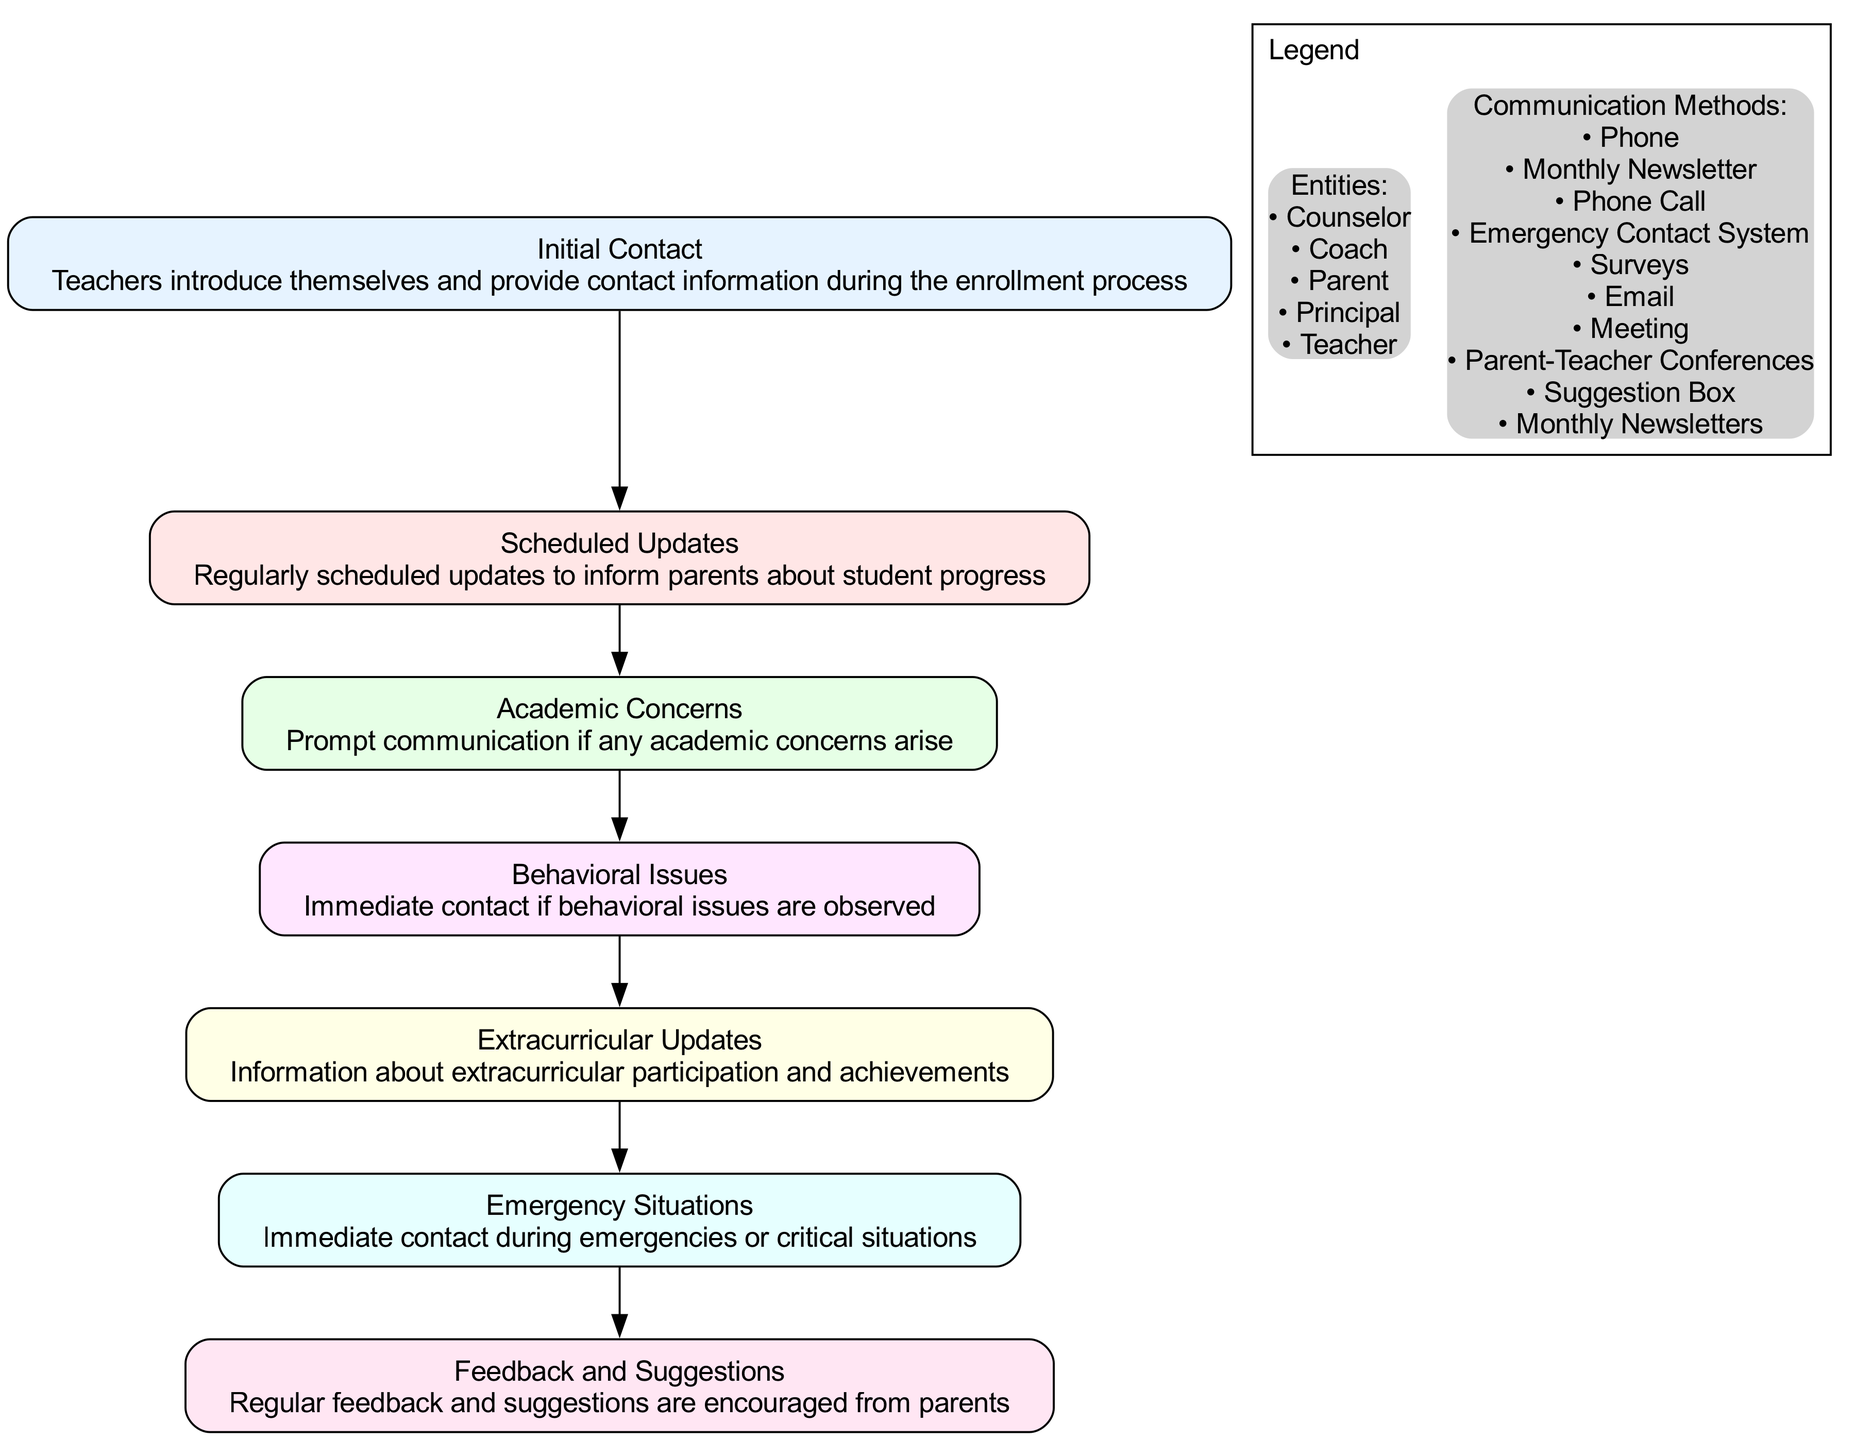What is the first step in the communication protocol? The first step is labeled "Initial Contact," which indicates that teachers introduce themselves and provide contact information during the enrollment process.
Answer: Initial Contact How many entities are involved in "Behavioral Issues"? The entities listed for "Behavioral Issues" are Teacher, Parent, and Counselor, which totals three entities involved in this step.
Answer: 3 What methods are used for "Scheduled Updates"? The methods for "Scheduled Updates" include Parent-Teacher Conferences and Monthly Newsletters, which are the two communication methods indicated at this step.
Answer: Parent-Teacher Conferences, Monthly Newsletters What step follows "Academic Concerns"? The step that directly follows "Academic Concerns" in the progression of the diagram is "Behavioral Issues," indicating the sequence of communication steps.
Answer: Behavioral Issues Which stakeholders are involved in "Emergency Situations"? The stakeholders involved in "Emergency Situations" include the Principal, Teacher, and Parent, as specified within this node in the diagram.
Answer: Principal, Teacher, Parent How is feedback encouraged from parents? Feedback from parents is encouraged through Surveys, Suggestion Box, and Meetings, as outlined in the "Feedback and Suggestions" step of the diagram.
Answer: Surveys, Suggestion Box, Meeting What is the purpose of "Extracurricular Updates"? The purpose of "Extracurricular Updates" is to provide information about extracurricular participation and achievements, specifically to keep parents informed about their child's involvement outside of academic activities.
Answer: Information about extracurricular participation and achievements How many steps are there in the diagram? The diagram outlines a total of seven steps, each representing different aspects of parent-teacher communication protocols.
Answer: 7 